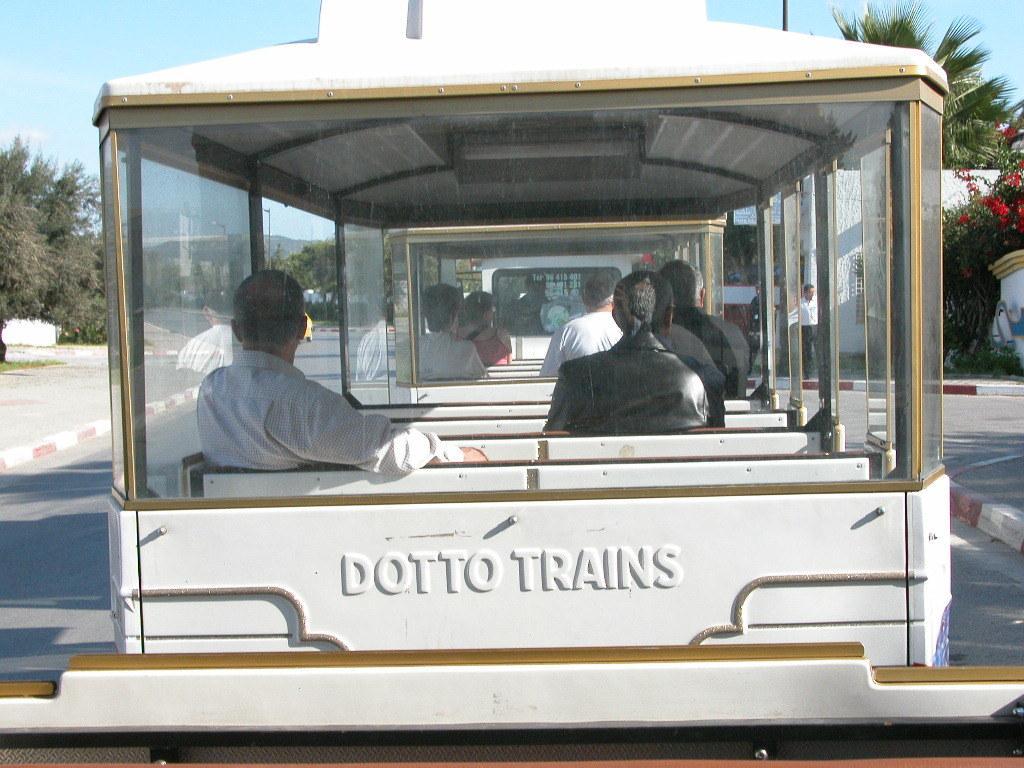In one or two sentences, can you explain what this image depicts? There are few people sitting in the vehicle. These are the glass doors. I can see the trees. This looks like a building. I can see a person standing near the building. This looks like a tree with red flowers. 